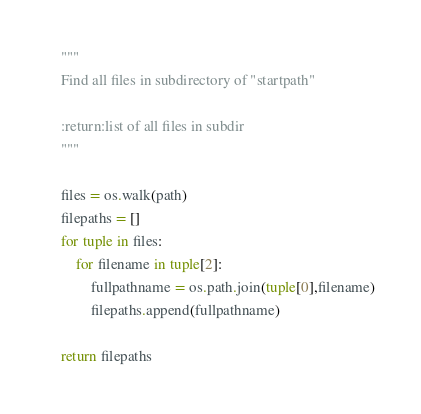<code> <loc_0><loc_0><loc_500><loc_500><_Python_>    """
    Find all files in subdirectory of "startpath"

    :return:list of all files in subdir
    """

    files = os.walk(path)
    filepaths = []
    for tuple in files:
        for filename in tuple[2]:
            fullpathname = os.path.join(tuple[0],filename)
            filepaths.append(fullpathname)

    return filepaths


</code> 